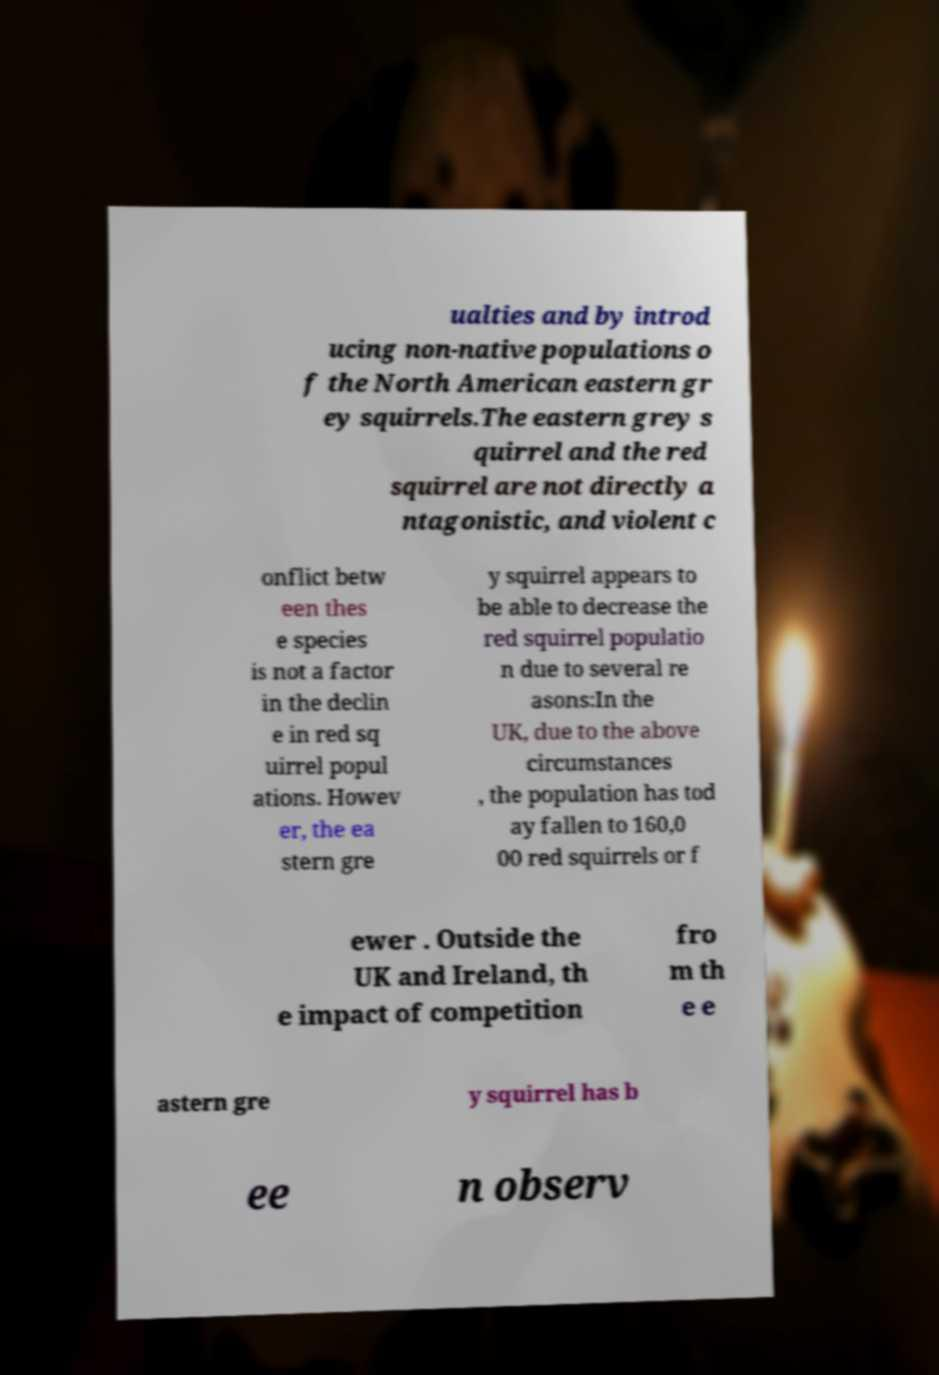Please read and relay the text visible in this image. What does it say? ualties and by introd ucing non-native populations o f the North American eastern gr ey squirrels.The eastern grey s quirrel and the red squirrel are not directly a ntagonistic, and violent c onflict betw een thes e species is not a factor in the declin e in red sq uirrel popul ations. Howev er, the ea stern gre y squirrel appears to be able to decrease the red squirrel populatio n due to several re asons:In the UK, due to the above circumstances , the population has tod ay fallen to 160,0 00 red squirrels or f ewer . Outside the UK and Ireland, th e impact of competition fro m th e e astern gre y squirrel has b ee n observ 